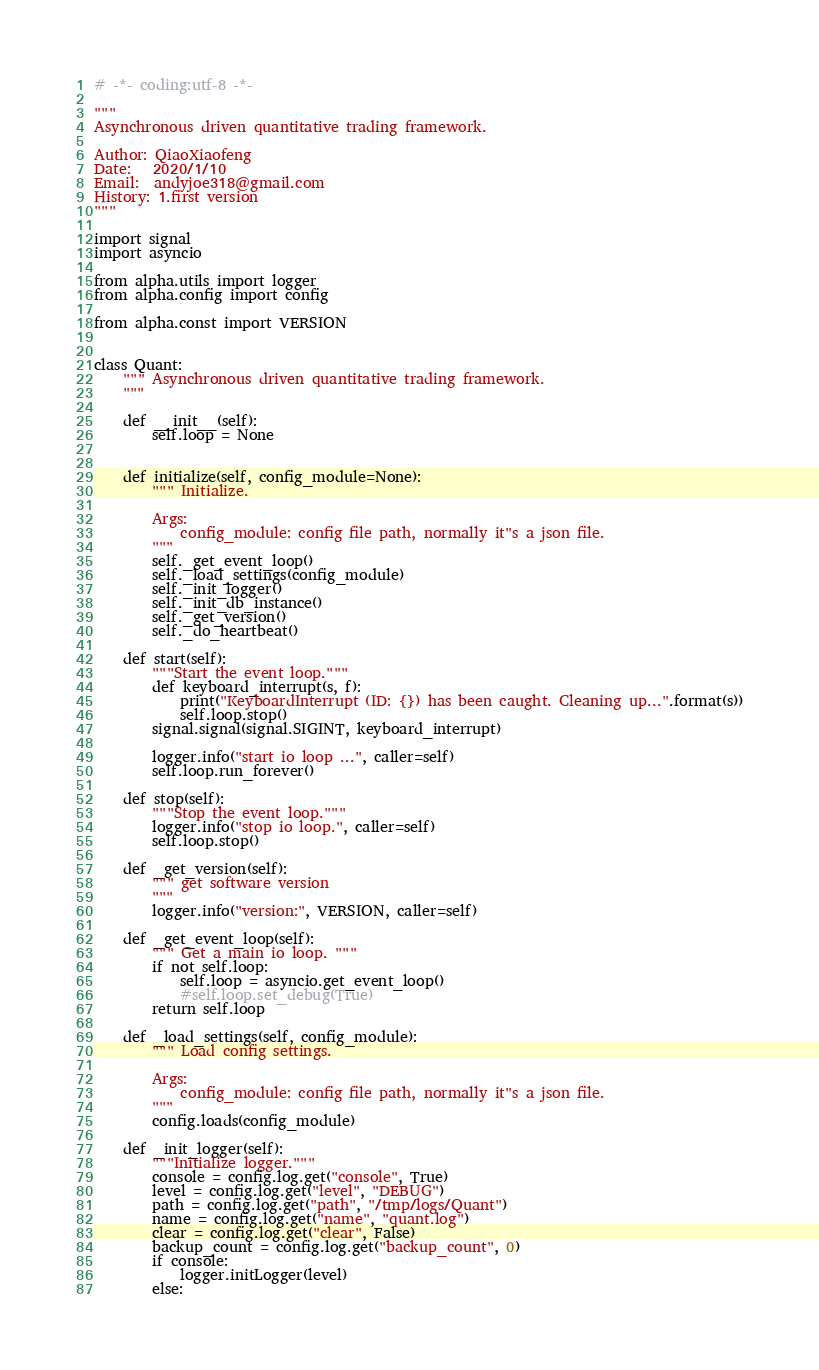<code> <loc_0><loc_0><loc_500><loc_500><_Python_># -*- coding:utf-8 -*-

"""
Asynchronous driven quantitative trading framework.

Author: QiaoXiaofeng
Date:   2020/1/10
Email:  andyjoe318@gmail.com
History: 1.first version
"""

import signal
import asyncio

from alpha.utils import logger
from alpha.config import config

from alpha.const import VERSION


class Quant:
    """ Asynchronous driven quantitative trading framework.
    """

    def __init__(self):
        self.loop = None


    def initialize(self, config_module=None):
        """ Initialize.

        Args:
            config_module: config file path, normally it"s a json file.
        """
        self._get_event_loop()
        self._load_settings(config_module)
        self._init_logger()
        self._init_db_instance()
        self._get_version()
        self._do_heartbeat()

    def start(self):
        """Start the event loop."""
        def keyboard_interrupt(s, f):
            print("KeyboardInterrupt (ID: {}) has been caught. Cleaning up...".format(s))
            self.loop.stop()
        signal.signal(signal.SIGINT, keyboard_interrupt)

        logger.info("start io loop ...", caller=self)
        self.loop.run_forever()

    def stop(self):
        """Stop the event loop."""
        logger.info("stop io loop.", caller=self)
        self.loop.stop()

    def _get_version(self):
        """ get software version
        """
        logger.info("version:", VERSION, caller=self)

    def _get_event_loop(self):
        """ Get a main io loop. """
        if not self.loop:
            self.loop = asyncio.get_event_loop()
            #self.loop.set_debug(True)
        return self.loop

    def _load_settings(self, config_module):
        """ Load config settings.

        Args:
            config_module: config file path, normally it"s a json file.
        """
        config.loads(config_module)

    def _init_logger(self):
        """Initialize logger."""
        console = config.log.get("console", True)
        level = config.log.get("level", "DEBUG")
        path = config.log.get("path", "/tmp/logs/Quant")
        name = config.log.get("name", "quant.log")
        clear = config.log.get("clear", False)
        backup_count = config.log.get("backup_count", 0)
        if console:
            logger.initLogger(level)
        else:</code> 